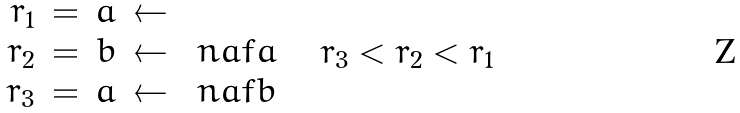<formula> <loc_0><loc_0><loc_500><loc_500>\begin{array} [ t ] { r c r c l } r _ { 1 } & = & a & \leftarrow & \\ r _ { 2 } & = & b & \leftarrow & \ n a f a \\ r _ { 3 } & = & a & \leftarrow & \ n a f b \end{array} \quad r _ { 3 } < r _ { 2 } < r _ { 1 }</formula> 